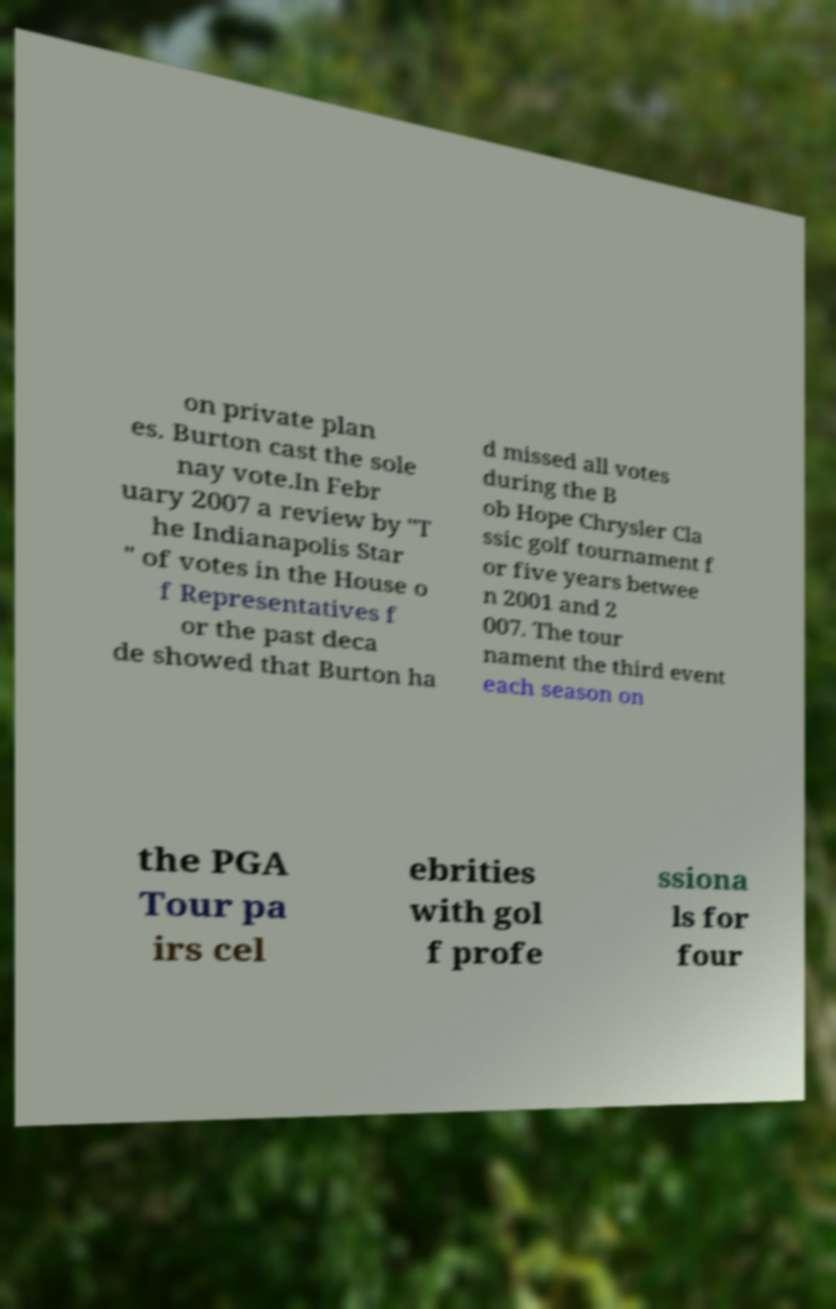I need the written content from this picture converted into text. Can you do that? on private plan es. Burton cast the sole nay vote.In Febr uary 2007 a review by "T he Indianapolis Star " of votes in the House o f Representatives f or the past deca de showed that Burton ha d missed all votes during the B ob Hope Chrysler Cla ssic golf tournament f or five years betwee n 2001 and 2 007. The tour nament the third event each season on the PGA Tour pa irs cel ebrities with gol f profe ssiona ls for four 